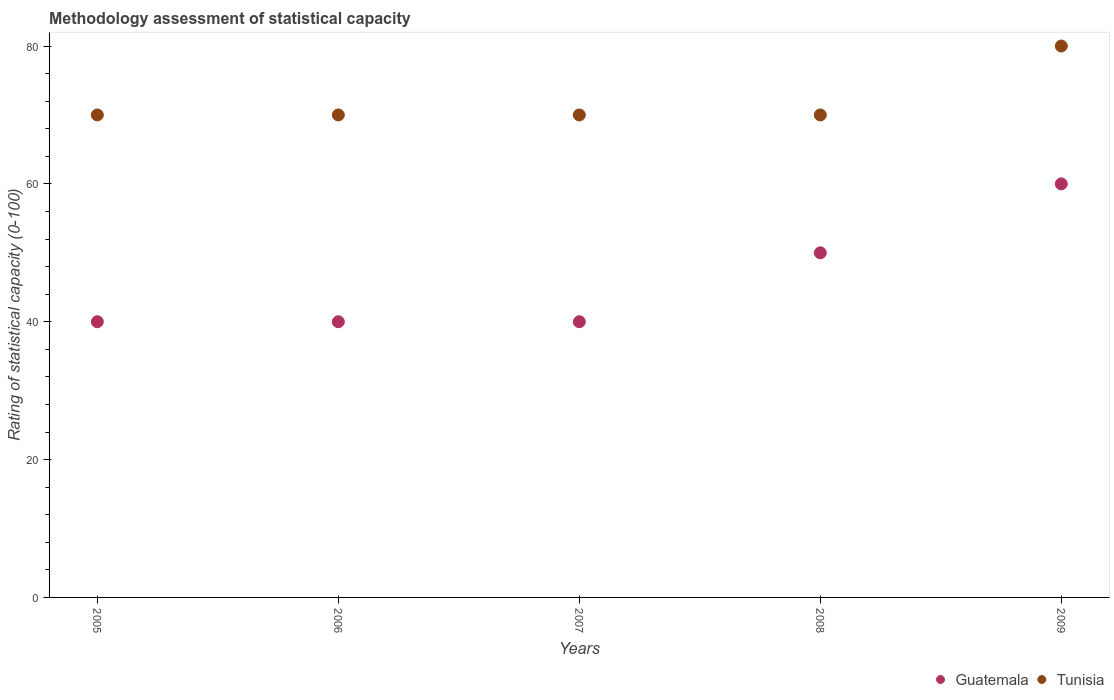How many different coloured dotlines are there?
Make the answer very short. 2. What is the rating of statistical capacity in Tunisia in 2006?
Provide a succinct answer. 70. Across all years, what is the maximum rating of statistical capacity in Guatemala?
Provide a short and direct response. 60. Across all years, what is the minimum rating of statistical capacity in Tunisia?
Your answer should be very brief. 70. In which year was the rating of statistical capacity in Tunisia minimum?
Provide a short and direct response. 2005. What is the total rating of statistical capacity in Guatemala in the graph?
Offer a terse response. 230. What is the difference between the rating of statistical capacity in Tunisia in 2005 and the rating of statistical capacity in Guatemala in 2009?
Keep it short and to the point. 10. What is the average rating of statistical capacity in Tunisia per year?
Provide a succinct answer. 72. In the year 2008, what is the difference between the rating of statistical capacity in Tunisia and rating of statistical capacity in Guatemala?
Provide a short and direct response. 20. In how many years, is the rating of statistical capacity in Guatemala greater than 64?
Make the answer very short. 0. What is the ratio of the rating of statistical capacity in Guatemala in 2007 to that in 2008?
Your answer should be very brief. 0.8. Is the rating of statistical capacity in Tunisia in 2005 less than that in 2008?
Make the answer very short. No. Is the difference between the rating of statistical capacity in Tunisia in 2008 and 2009 greater than the difference between the rating of statistical capacity in Guatemala in 2008 and 2009?
Your answer should be very brief. No. What is the difference between the highest and the lowest rating of statistical capacity in Guatemala?
Provide a succinct answer. 20. Does the rating of statistical capacity in Tunisia monotonically increase over the years?
Give a very brief answer. No. Is the rating of statistical capacity in Guatemala strictly less than the rating of statistical capacity in Tunisia over the years?
Offer a very short reply. Yes. How many dotlines are there?
Offer a very short reply. 2. Are the values on the major ticks of Y-axis written in scientific E-notation?
Give a very brief answer. No. Does the graph contain any zero values?
Keep it short and to the point. No. Does the graph contain grids?
Offer a very short reply. No. Where does the legend appear in the graph?
Provide a succinct answer. Bottom right. How many legend labels are there?
Offer a terse response. 2. What is the title of the graph?
Keep it short and to the point. Methodology assessment of statistical capacity. Does "Seychelles" appear as one of the legend labels in the graph?
Make the answer very short. No. What is the label or title of the X-axis?
Offer a very short reply. Years. What is the label or title of the Y-axis?
Give a very brief answer. Rating of statistical capacity (0-100). What is the Rating of statistical capacity (0-100) in Guatemala in 2005?
Your answer should be compact. 40. What is the Rating of statistical capacity (0-100) of Tunisia in 2005?
Keep it short and to the point. 70. What is the Rating of statistical capacity (0-100) of Guatemala in 2006?
Give a very brief answer. 40. What is the Rating of statistical capacity (0-100) in Tunisia in 2007?
Give a very brief answer. 70. What is the Rating of statistical capacity (0-100) in Guatemala in 2008?
Offer a terse response. 50. What is the Rating of statistical capacity (0-100) in Tunisia in 2008?
Provide a short and direct response. 70. What is the Rating of statistical capacity (0-100) of Guatemala in 2009?
Your response must be concise. 60. What is the Rating of statistical capacity (0-100) of Tunisia in 2009?
Your answer should be very brief. 80. Across all years, what is the maximum Rating of statistical capacity (0-100) in Guatemala?
Your answer should be very brief. 60. What is the total Rating of statistical capacity (0-100) of Guatemala in the graph?
Make the answer very short. 230. What is the total Rating of statistical capacity (0-100) in Tunisia in the graph?
Offer a very short reply. 360. What is the difference between the Rating of statistical capacity (0-100) in Guatemala in 2005 and that in 2007?
Your response must be concise. 0. What is the difference between the Rating of statistical capacity (0-100) in Tunisia in 2005 and that in 2007?
Make the answer very short. 0. What is the difference between the Rating of statistical capacity (0-100) in Guatemala in 2005 and that in 2008?
Offer a terse response. -10. What is the difference between the Rating of statistical capacity (0-100) of Tunisia in 2005 and that in 2008?
Your answer should be compact. 0. What is the difference between the Rating of statistical capacity (0-100) of Guatemala in 2006 and that in 2008?
Offer a very short reply. -10. What is the difference between the Rating of statistical capacity (0-100) in Tunisia in 2006 and that in 2008?
Keep it short and to the point. 0. What is the difference between the Rating of statistical capacity (0-100) of Tunisia in 2006 and that in 2009?
Your answer should be very brief. -10. What is the difference between the Rating of statistical capacity (0-100) of Guatemala in 2007 and that in 2008?
Keep it short and to the point. -10. What is the difference between the Rating of statistical capacity (0-100) of Guatemala in 2007 and that in 2009?
Your response must be concise. -20. What is the difference between the Rating of statistical capacity (0-100) of Guatemala in 2008 and that in 2009?
Give a very brief answer. -10. What is the difference between the Rating of statistical capacity (0-100) of Guatemala in 2005 and the Rating of statistical capacity (0-100) of Tunisia in 2006?
Your response must be concise. -30. What is the difference between the Rating of statistical capacity (0-100) in Guatemala in 2005 and the Rating of statistical capacity (0-100) in Tunisia in 2008?
Your response must be concise. -30. What is the difference between the Rating of statistical capacity (0-100) in Guatemala in 2005 and the Rating of statistical capacity (0-100) in Tunisia in 2009?
Make the answer very short. -40. What is the difference between the Rating of statistical capacity (0-100) in Guatemala in 2006 and the Rating of statistical capacity (0-100) in Tunisia in 2007?
Offer a very short reply. -30. What is the difference between the Rating of statistical capacity (0-100) in Guatemala in 2007 and the Rating of statistical capacity (0-100) in Tunisia in 2009?
Keep it short and to the point. -40. What is the difference between the Rating of statistical capacity (0-100) of Guatemala in 2008 and the Rating of statistical capacity (0-100) of Tunisia in 2009?
Provide a succinct answer. -30. What is the average Rating of statistical capacity (0-100) of Guatemala per year?
Give a very brief answer. 46. In the year 2006, what is the difference between the Rating of statistical capacity (0-100) in Guatemala and Rating of statistical capacity (0-100) in Tunisia?
Your response must be concise. -30. In the year 2007, what is the difference between the Rating of statistical capacity (0-100) in Guatemala and Rating of statistical capacity (0-100) in Tunisia?
Ensure brevity in your answer.  -30. What is the ratio of the Rating of statistical capacity (0-100) of Guatemala in 2005 to that in 2006?
Keep it short and to the point. 1. What is the ratio of the Rating of statistical capacity (0-100) of Guatemala in 2005 to that in 2008?
Your response must be concise. 0.8. What is the ratio of the Rating of statistical capacity (0-100) of Guatemala in 2006 to that in 2007?
Your answer should be compact. 1. What is the ratio of the Rating of statistical capacity (0-100) in Tunisia in 2006 to that in 2007?
Make the answer very short. 1. What is the ratio of the Rating of statistical capacity (0-100) in Tunisia in 2007 to that in 2009?
Make the answer very short. 0.88. What is the ratio of the Rating of statistical capacity (0-100) of Guatemala in 2008 to that in 2009?
Your answer should be compact. 0.83. What is the difference between the highest and the lowest Rating of statistical capacity (0-100) in Guatemala?
Keep it short and to the point. 20. 